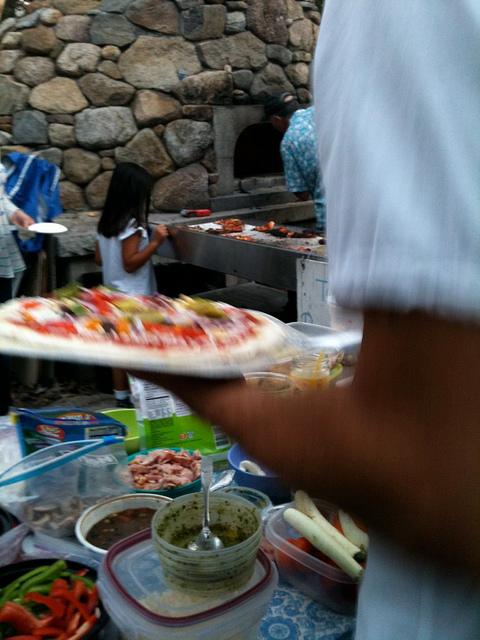What color is the girls hair?
Give a very brief answer. Black. How strands of cheese are on the pizza?
Write a very short answer. 100. Is the plastic container with the spoon in it full?
Give a very brief answer. No. 